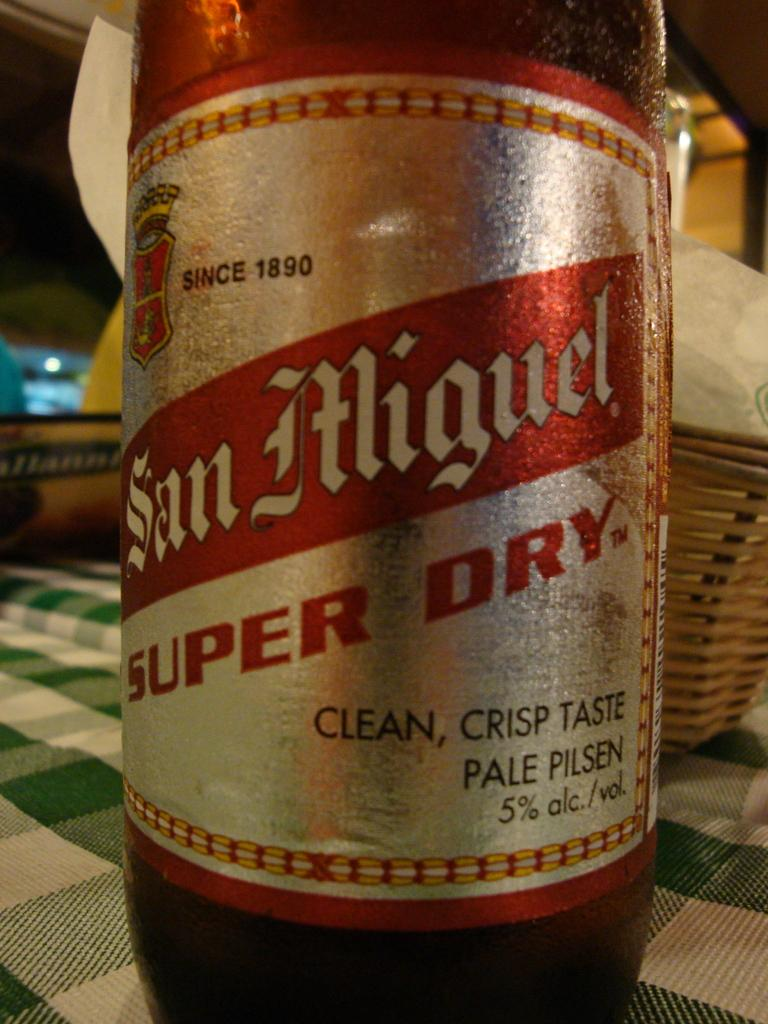<image>
Present a compact description of the photo's key features. A bottle of San Miguel that has 5% alcohol. 